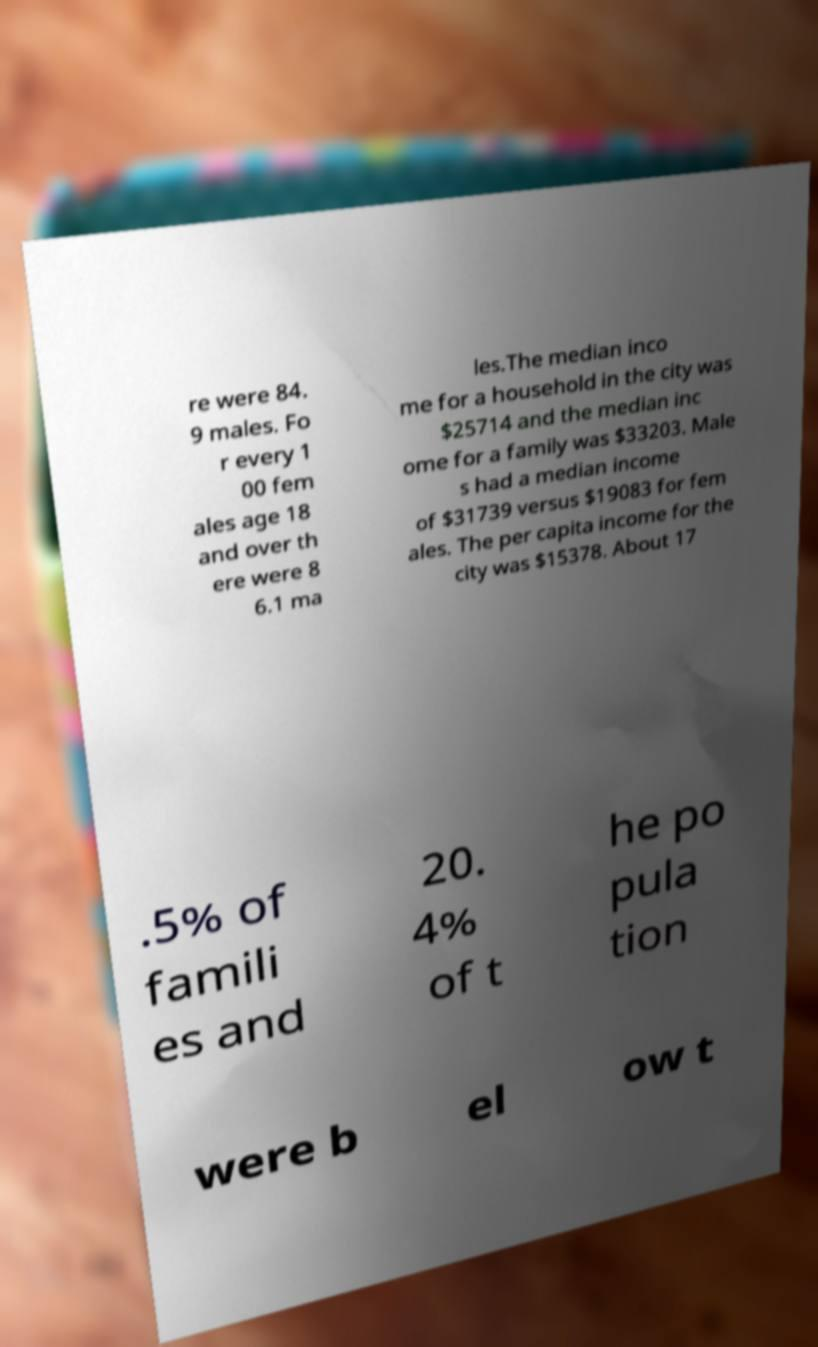Please read and relay the text visible in this image. What does it say? re were 84. 9 males. Fo r every 1 00 fem ales age 18 and over th ere were 8 6.1 ma les.The median inco me for a household in the city was $25714 and the median inc ome for a family was $33203. Male s had a median income of $31739 versus $19083 for fem ales. The per capita income for the city was $15378. About 17 .5% of famili es and 20. 4% of t he po pula tion were b el ow t 